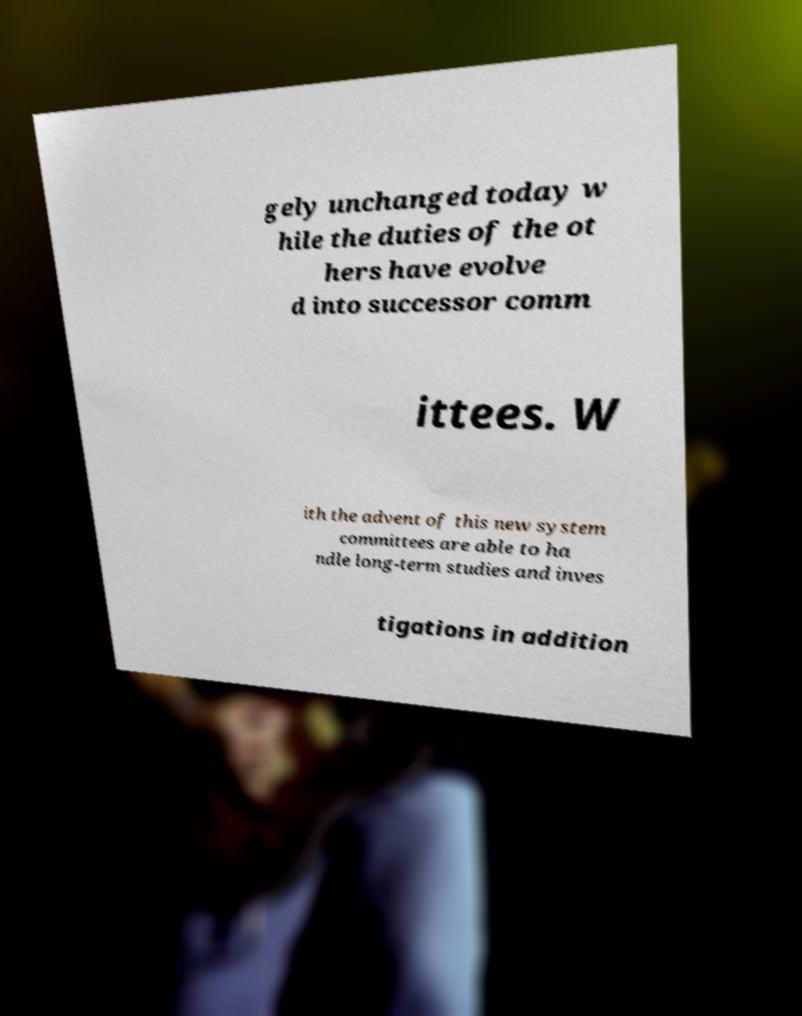I need the written content from this picture converted into text. Can you do that? gely unchanged today w hile the duties of the ot hers have evolve d into successor comm ittees. W ith the advent of this new system committees are able to ha ndle long-term studies and inves tigations in addition 